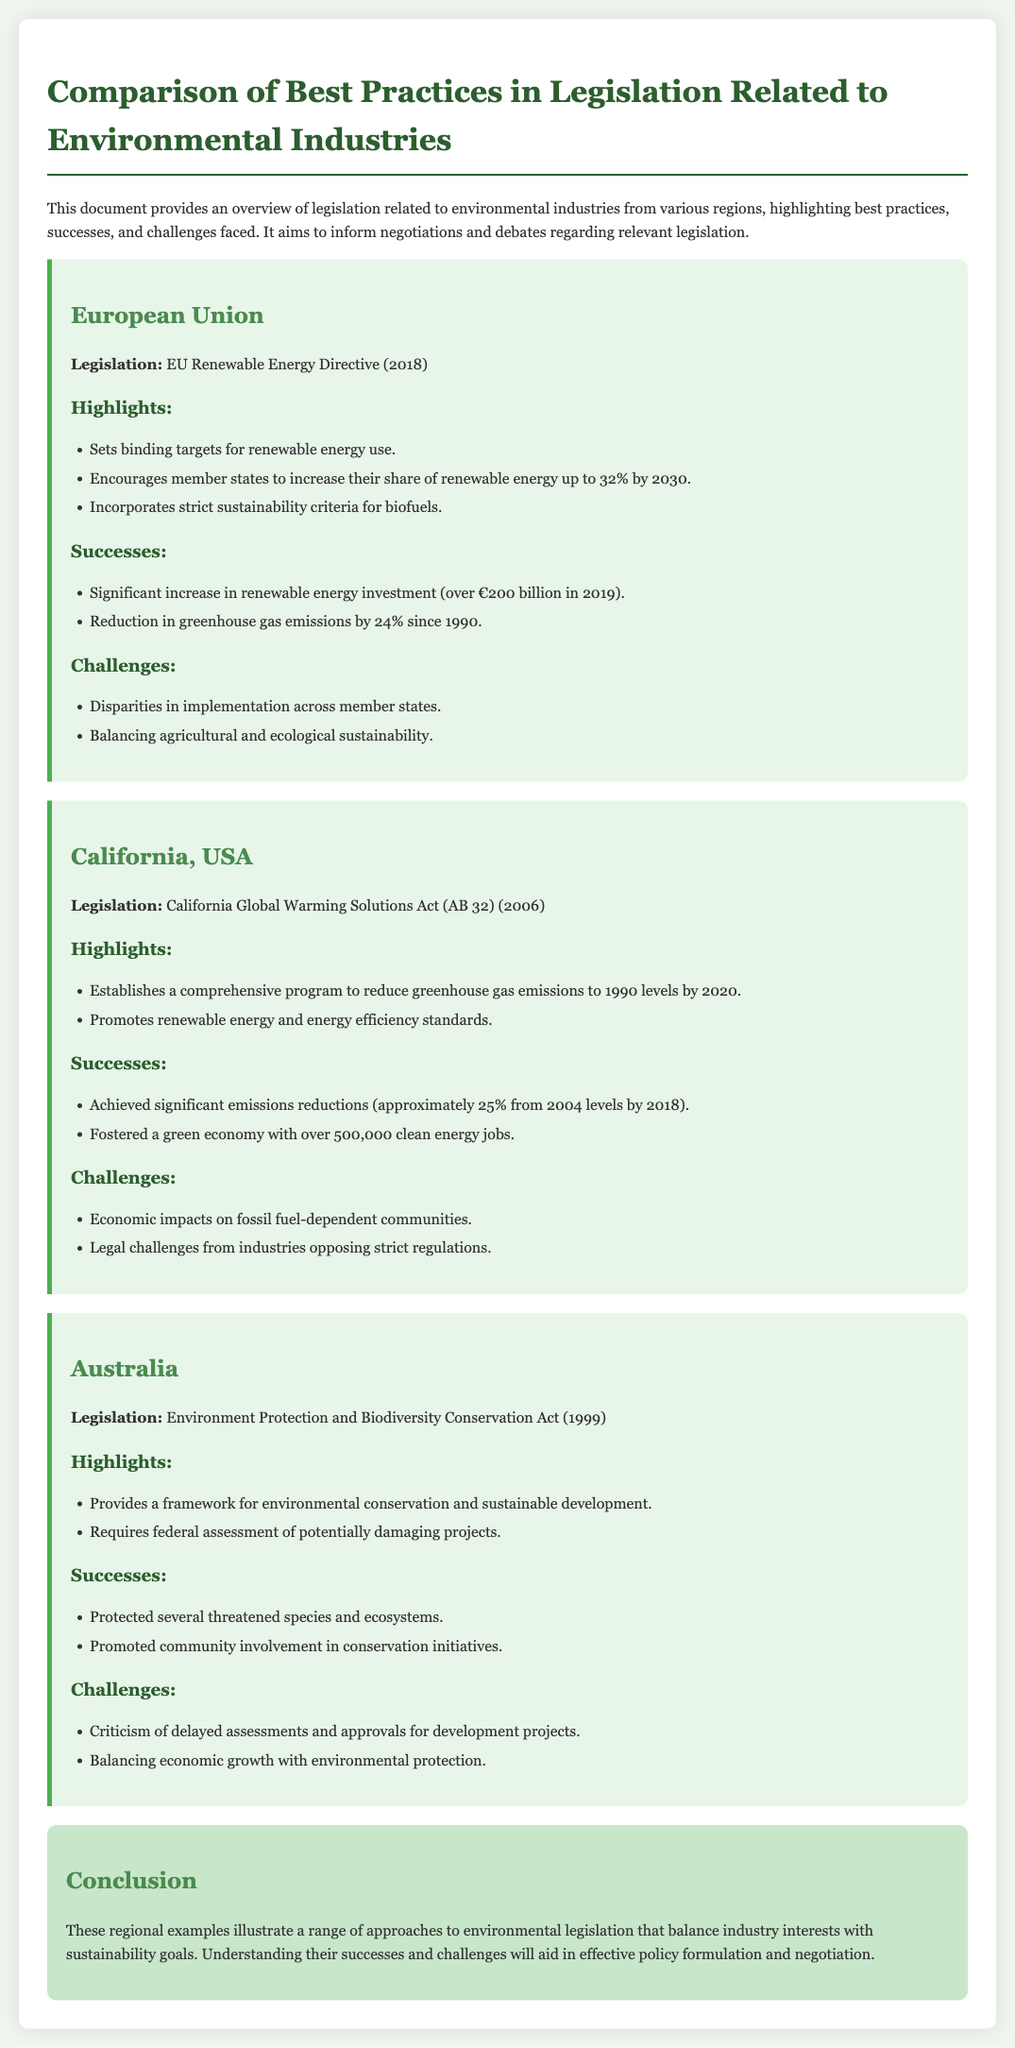What is the legislation from the European Union? The document states that the legislation from the European Union is the EU Renewable Energy Directive (2018).
Answer: EU Renewable Energy Directive (2018) What is the binding target for renewable energy use in the EU by 2030? According to the highlights in the document, the binding target for renewable energy use in the EU is up to 32% by 2030.
Answer: 32% What year was the California Global Warming Solutions Act enacted? The document indicates that the California Global Warming Solutions Act (AB 32) was enacted in 2006.
Answer: 2006 What is one major success achieved under California's legislation? The document notes that a significant success under California's legislation is that emissions were reduced by approximately 25% from 2004 levels by 2018.
Answer: 25% What issue faced by Australia’s legislation involves project assessments? The document highlights that Australia’s legislation faces criticism of delayed assessments and approvals for development projects.
Answer: Delayed assessments What is the framework provided by Australia's legislation? The document specifies that Australia’s legislation provides a framework for environmental conservation and sustainable development.
Answer: Environmental conservation and sustainable development What significant outcome was reached in the EU regarding greenhouse gas emissions? The document mentions that the EU achieved a reduction in greenhouse gas emissions by 24% since 1990.
Answer: 24% What was a key challenge faced by the EU in implementing its legislation? The document states that a key challenge faced by the EU is the disparities in implementation across member states.
Answer: Disparities in implementation What is the general purpose of the document? The document aims to provide an overview of legislation related to environmental industries to inform negotiations and debates.
Answer: Inform negotiations and debates 